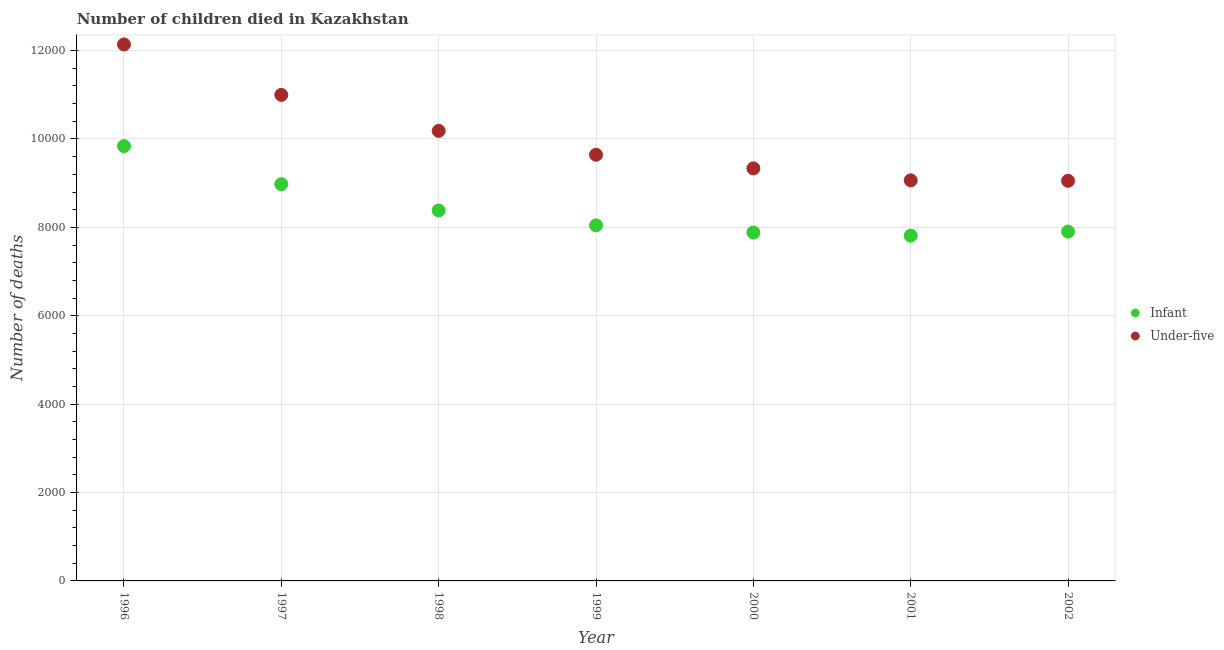How many different coloured dotlines are there?
Provide a short and direct response. 2. Is the number of dotlines equal to the number of legend labels?
Give a very brief answer. Yes. What is the number of infant deaths in 2001?
Your answer should be very brief. 7812. Across all years, what is the maximum number of infant deaths?
Give a very brief answer. 9839. Across all years, what is the minimum number of under-five deaths?
Your answer should be compact. 9054. In which year was the number of under-five deaths maximum?
Provide a succinct answer. 1996. In which year was the number of infant deaths minimum?
Your answer should be very brief. 2001. What is the total number of under-five deaths in the graph?
Give a very brief answer. 7.04e+04. What is the difference between the number of infant deaths in 1996 and that in 2000?
Ensure brevity in your answer.  1956. What is the difference between the number of infant deaths in 1997 and the number of under-five deaths in 2001?
Offer a terse response. -87. What is the average number of under-five deaths per year?
Make the answer very short. 1.01e+04. In the year 2001, what is the difference between the number of infant deaths and number of under-five deaths?
Your response must be concise. -1252. What is the ratio of the number of infant deaths in 2001 to that in 2002?
Provide a short and direct response. 0.99. Is the number of under-five deaths in 1997 less than that in 1999?
Keep it short and to the point. No. Is the difference between the number of under-five deaths in 1996 and 1998 greater than the difference between the number of infant deaths in 1996 and 1998?
Provide a short and direct response. Yes. What is the difference between the highest and the second highest number of under-five deaths?
Keep it short and to the point. 1141. What is the difference between the highest and the lowest number of under-five deaths?
Your answer should be compact. 3085. Is the sum of the number of under-five deaths in 1998 and 2002 greater than the maximum number of infant deaths across all years?
Provide a short and direct response. Yes. Is the number of infant deaths strictly greater than the number of under-five deaths over the years?
Ensure brevity in your answer.  No. Is the number of infant deaths strictly less than the number of under-five deaths over the years?
Offer a very short reply. Yes. How many years are there in the graph?
Provide a short and direct response. 7. What is the difference between two consecutive major ticks on the Y-axis?
Your answer should be compact. 2000. Are the values on the major ticks of Y-axis written in scientific E-notation?
Provide a short and direct response. No. Does the graph contain any zero values?
Ensure brevity in your answer.  No. How many legend labels are there?
Provide a short and direct response. 2. What is the title of the graph?
Provide a succinct answer. Number of children died in Kazakhstan. Does "GDP" appear as one of the legend labels in the graph?
Make the answer very short. No. What is the label or title of the X-axis?
Your answer should be compact. Year. What is the label or title of the Y-axis?
Provide a short and direct response. Number of deaths. What is the Number of deaths of Infant in 1996?
Provide a succinct answer. 9839. What is the Number of deaths in Under-five in 1996?
Your answer should be compact. 1.21e+04. What is the Number of deaths of Infant in 1997?
Make the answer very short. 8977. What is the Number of deaths in Under-five in 1997?
Offer a very short reply. 1.10e+04. What is the Number of deaths of Infant in 1998?
Offer a very short reply. 8383. What is the Number of deaths in Under-five in 1998?
Your response must be concise. 1.02e+04. What is the Number of deaths of Infant in 1999?
Offer a very short reply. 8045. What is the Number of deaths in Under-five in 1999?
Your answer should be compact. 9643. What is the Number of deaths in Infant in 2000?
Provide a succinct answer. 7883. What is the Number of deaths in Under-five in 2000?
Your answer should be compact. 9335. What is the Number of deaths in Infant in 2001?
Make the answer very short. 7812. What is the Number of deaths of Under-five in 2001?
Provide a short and direct response. 9064. What is the Number of deaths of Infant in 2002?
Offer a very short reply. 7904. What is the Number of deaths of Under-five in 2002?
Give a very brief answer. 9054. Across all years, what is the maximum Number of deaths in Infant?
Keep it short and to the point. 9839. Across all years, what is the maximum Number of deaths in Under-five?
Your response must be concise. 1.21e+04. Across all years, what is the minimum Number of deaths of Infant?
Provide a succinct answer. 7812. Across all years, what is the minimum Number of deaths of Under-five?
Provide a short and direct response. 9054. What is the total Number of deaths in Infant in the graph?
Your answer should be compact. 5.88e+04. What is the total Number of deaths of Under-five in the graph?
Provide a short and direct response. 7.04e+04. What is the difference between the Number of deaths in Infant in 1996 and that in 1997?
Your answer should be very brief. 862. What is the difference between the Number of deaths of Under-five in 1996 and that in 1997?
Ensure brevity in your answer.  1141. What is the difference between the Number of deaths of Infant in 1996 and that in 1998?
Keep it short and to the point. 1456. What is the difference between the Number of deaths in Under-five in 1996 and that in 1998?
Your response must be concise. 1956. What is the difference between the Number of deaths of Infant in 1996 and that in 1999?
Your answer should be compact. 1794. What is the difference between the Number of deaths of Under-five in 1996 and that in 1999?
Provide a succinct answer. 2496. What is the difference between the Number of deaths in Infant in 1996 and that in 2000?
Offer a very short reply. 1956. What is the difference between the Number of deaths in Under-five in 1996 and that in 2000?
Make the answer very short. 2804. What is the difference between the Number of deaths of Infant in 1996 and that in 2001?
Give a very brief answer. 2027. What is the difference between the Number of deaths in Under-five in 1996 and that in 2001?
Make the answer very short. 3075. What is the difference between the Number of deaths of Infant in 1996 and that in 2002?
Offer a terse response. 1935. What is the difference between the Number of deaths in Under-five in 1996 and that in 2002?
Your answer should be very brief. 3085. What is the difference between the Number of deaths of Infant in 1997 and that in 1998?
Your answer should be very brief. 594. What is the difference between the Number of deaths of Under-five in 1997 and that in 1998?
Provide a short and direct response. 815. What is the difference between the Number of deaths in Infant in 1997 and that in 1999?
Offer a terse response. 932. What is the difference between the Number of deaths in Under-five in 1997 and that in 1999?
Provide a succinct answer. 1355. What is the difference between the Number of deaths of Infant in 1997 and that in 2000?
Your answer should be very brief. 1094. What is the difference between the Number of deaths in Under-five in 1997 and that in 2000?
Provide a short and direct response. 1663. What is the difference between the Number of deaths of Infant in 1997 and that in 2001?
Give a very brief answer. 1165. What is the difference between the Number of deaths of Under-five in 1997 and that in 2001?
Your answer should be very brief. 1934. What is the difference between the Number of deaths of Infant in 1997 and that in 2002?
Keep it short and to the point. 1073. What is the difference between the Number of deaths in Under-five in 1997 and that in 2002?
Offer a terse response. 1944. What is the difference between the Number of deaths of Infant in 1998 and that in 1999?
Give a very brief answer. 338. What is the difference between the Number of deaths of Under-five in 1998 and that in 1999?
Your answer should be compact. 540. What is the difference between the Number of deaths in Under-five in 1998 and that in 2000?
Offer a very short reply. 848. What is the difference between the Number of deaths of Infant in 1998 and that in 2001?
Your answer should be compact. 571. What is the difference between the Number of deaths in Under-five in 1998 and that in 2001?
Your response must be concise. 1119. What is the difference between the Number of deaths of Infant in 1998 and that in 2002?
Make the answer very short. 479. What is the difference between the Number of deaths in Under-five in 1998 and that in 2002?
Provide a short and direct response. 1129. What is the difference between the Number of deaths of Infant in 1999 and that in 2000?
Provide a short and direct response. 162. What is the difference between the Number of deaths of Under-five in 1999 and that in 2000?
Your answer should be compact. 308. What is the difference between the Number of deaths of Infant in 1999 and that in 2001?
Your answer should be compact. 233. What is the difference between the Number of deaths of Under-five in 1999 and that in 2001?
Offer a terse response. 579. What is the difference between the Number of deaths in Infant in 1999 and that in 2002?
Ensure brevity in your answer.  141. What is the difference between the Number of deaths in Under-five in 1999 and that in 2002?
Provide a succinct answer. 589. What is the difference between the Number of deaths in Under-five in 2000 and that in 2001?
Your answer should be very brief. 271. What is the difference between the Number of deaths of Infant in 2000 and that in 2002?
Keep it short and to the point. -21. What is the difference between the Number of deaths in Under-five in 2000 and that in 2002?
Your answer should be very brief. 281. What is the difference between the Number of deaths of Infant in 2001 and that in 2002?
Offer a terse response. -92. What is the difference between the Number of deaths of Infant in 1996 and the Number of deaths of Under-five in 1997?
Your answer should be compact. -1159. What is the difference between the Number of deaths of Infant in 1996 and the Number of deaths of Under-five in 1998?
Provide a succinct answer. -344. What is the difference between the Number of deaths in Infant in 1996 and the Number of deaths in Under-five in 1999?
Ensure brevity in your answer.  196. What is the difference between the Number of deaths of Infant in 1996 and the Number of deaths of Under-five in 2000?
Keep it short and to the point. 504. What is the difference between the Number of deaths in Infant in 1996 and the Number of deaths in Under-five in 2001?
Offer a terse response. 775. What is the difference between the Number of deaths of Infant in 1996 and the Number of deaths of Under-five in 2002?
Make the answer very short. 785. What is the difference between the Number of deaths of Infant in 1997 and the Number of deaths of Under-five in 1998?
Ensure brevity in your answer.  -1206. What is the difference between the Number of deaths in Infant in 1997 and the Number of deaths in Under-five in 1999?
Make the answer very short. -666. What is the difference between the Number of deaths of Infant in 1997 and the Number of deaths of Under-five in 2000?
Your response must be concise. -358. What is the difference between the Number of deaths of Infant in 1997 and the Number of deaths of Under-five in 2001?
Offer a terse response. -87. What is the difference between the Number of deaths in Infant in 1997 and the Number of deaths in Under-five in 2002?
Provide a succinct answer. -77. What is the difference between the Number of deaths of Infant in 1998 and the Number of deaths of Under-five in 1999?
Offer a very short reply. -1260. What is the difference between the Number of deaths of Infant in 1998 and the Number of deaths of Under-five in 2000?
Your answer should be compact. -952. What is the difference between the Number of deaths in Infant in 1998 and the Number of deaths in Under-five in 2001?
Give a very brief answer. -681. What is the difference between the Number of deaths in Infant in 1998 and the Number of deaths in Under-five in 2002?
Ensure brevity in your answer.  -671. What is the difference between the Number of deaths of Infant in 1999 and the Number of deaths of Under-five in 2000?
Make the answer very short. -1290. What is the difference between the Number of deaths of Infant in 1999 and the Number of deaths of Under-five in 2001?
Your answer should be compact. -1019. What is the difference between the Number of deaths of Infant in 1999 and the Number of deaths of Under-five in 2002?
Make the answer very short. -1009. What is the difference between the Number of deaths of Infant in 2000 and the Number of deaths of Under-five in 2001?
Your response must be concise. -1181. What is the difference between the Number of deaths in Infant in 2000 and the Number of deaths in Under-five in 2002?
Your answer should be very brief. -1171. What is the difference between the Number of deaths in Infant in 2001 and the Number of deaths in Under-five in 2002?
Offer a very short reply. -1242. What is the average Number of deaths in Infant per year?
Ensure brevity in your answer.  8406.14. What is the average Number of deaths of Under-five per year?
Provide a short and direct response. 1.01e+04. In the year 1996, what is the difference between the Number of deaths of Infant and Number of deaths of Under-five?
Provide a short and direct response. -2300. In the year 1997, what is the difference between the Number of deaths of Infant and Number of deaths of Under-five?
Ensure brevity in your answer.  -2021. In the year 1998, what is the difference between the Number of deaths in Infant and Number of deaths in Under-five?
Give a very brief answer. -1800. In the year 1999, what is the difference between the Number of deaths in Infant and Number of deaths in Under-five?
Your answer should be compact. -1598. In the year 2000, what is the difference between the Number of deaths in Infant and Number of deaths in Under-five?
Your answer should be compact. -1452. In the year 2001, what is the difference between the Number of deaths in Infant and Number of deaths in Under-five?
Offer a very short reply. -1252. In the year 2002, what is the difference between the Number of deaths of Infant and Number of deaths of Under-five?
Your answer should be compact. -1150. What is the ratio of the Number of deaths of Infant in 1996 to that in 1997?
Your answer should be compact. 1.1. What is the ratio of the Number of deaths in Under-five in 1996 to that in 1997?
Ensure brevity in your answer.  1.1. What is the ratio of the Number of deaths in Infant in 1996 to that in 1998?
Ensure brevity in your answer.  1.17. What is the ratio of the Number of deaths in Under-five in 1996 to that in 1998?
Give a very brief answer. 1.19. What is the ratio of the Number of deaths in Infant in 1996 to that in 1999?
Give a very brief answer. 1.22. What is the ratio of the Number of deaths in Under-five in 1996 to that in 1999?
Provide a short and direct response. 1.26. What is the ratio of the Number of deaths of Infant in 1996 to that in 2000?
Provide a short and direct response. 1.25. What is the ratio of the Number of deaths in Under-five in 1996 to that in 2000?
Your response must be concise. 1.3. What is the ratio of the Number of deaths of Infant in 1996 to that in 2001?
Give a very brief answer. 1.26. What is the ratio of the Number of deaths of Under-five in 1996 to that in 2001?
Provide a succinct answer. 1.34. What is the ratio of the Number of deaths of Infant in 1996 to that in 2002?
Make the answer very short. 1.24. What is the ratio of the Number of deaths of Under-five in 1996 to that in 2002?
Make the answer very short. 1.34. What is the ratio of the Number of deaths of Infant in 1997 to that in 1998?
Provide a succinct answer. 1.07. What is the ratio of the Number of deaths of Under-five in 1997 to that in 1998?
Provide a short and direct response. 1.08. What is the ratio of the Number of deaths of Infant in 1997 to that in 1999?
Offer a very short reply. 1.12. What is the ratio of the Number of deaths in Under-five in 1997 to that in 1999?
Ensure brevity in your answer.  1.14. What is the ratio of the Number of deaths in Infant in 1997 to that in 2000?
Give a very brief answer. 1.14. What is the ratio of the Number of deaths in Under-five in 1997 to that in 2000?
Offer a terse response. 1.18. What is the ratio of the Number of deaths in Infant in 1997 to that in 2001?
Provide a short and direct response. 1.15. What is the ratio of the Number of deaths of Under-five in 1997 to that in 2001?
Your answer should be very brief. 1.21. What is the ratio of the Number of deaths in Infant in 1997 to that in 2002?
Your response must be concise. 1.14. What is the ratio of the Number of deaths in Under-five in 1997 to that in 2002?
Keep it short and to the point. 1.21. What is the ratio of the Number of deaths in Infant in 1998 to that in 1999?
Your response must be concise. 1.04. What is the ratio of the Number of deaths of Under-five in 1998 to that in 1999?
Your answer should be very brief. 1.06. What is the ratio of the Number of deaths of Infant in 1998 to that in 2000?
Your answer should be compact. 1.06. What is the ratio of the Number of deaths of Under-five in 1998 to that in 2000?
Your answer should be very brief. 1.09. What is the ratio of the Number of deaths in Infant in 1998 to that in 2001?
Offer a terse response. 1.07. What is the ratio of the Number of deaths of Under-five in 1998 to that in 2001?
Offer a very short reply. 1.12. What is the ratio of the Number of deaths of Infant in 1998 to that in 2002?
Your answer should be compact. 1.06. What is the ratio of the Number of deaths in Under-five in 1998 to that in 2002?
Your answer should be compact. 1.12. What is the ratio of the Number of deaths in Infant in 1999 to that in 2000?
Make the answer very short. 1.02. What is the ratio of the Number of deaths in Under-five in 1999 to that in 2000?
Provide a short and direct response. 1.03. What is the ratio of the Number of deaths of Infant in 1999 to that in 2001?
Give a very brief answer. 1.03. What is the ratio of the Number of deaths of Under-five in 1999 to that in 2001?
Your response must be concise. 1.06. What is the ratio of the Number of deaths of Infant in 1999 to that in 2002?
Make the answer very short. 1.02. What is the ratio of the Number of deaths in Under-five in 1999 to that in 2002?
Provide a succinct answer. 1.07. What is the ratio of the Number of deaths of Infant in 2000 to that in 2001?
Your answer should be very brief. 1.01. What is the ratio of the Number of deaths in Under-five in 2000 to that in 2001?
Your answer should be compact. 1.03. What is the ratio of the Number of deaths of Infant in 2000 to that in 2002?
Your answer should be compact. 1. What is the ratio of the Number of deaths of Under-five in 2000 to that in 2002?
Keep it short and to the point. 1.03. What is the ratio of the Number of deaths in Infant in 2001 to that in 2002?
Keep it short and to the point. 0.99. What is the ratio of the Number of deaths of Under-five in 2001 to that in 2002?
Your answer should be compact. 1. What is the difference between the highest and the second highest Number of deaths of Infant?
Make the answer very short. 862. What is the difference between the highest and the second highest Number of deaths in Under-five?
Ensure brevity in your answer.  1141. What is the difference between the highest and the lowest Number of deaths in Infant?
Your answer should be very brief. 2027. What is the difference between the highest and the lowest Number of deaths of Under-five?
Your response must be concise. 3085. 